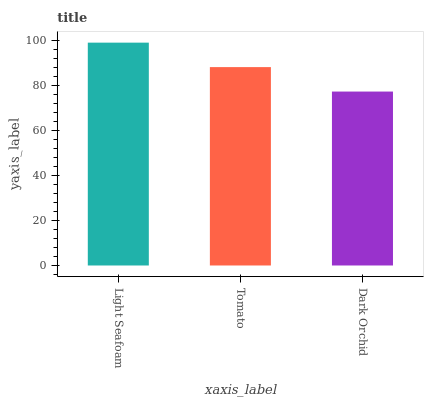Is Dark Orchid the minimum?
Answer yes or no. Yes. Is Light Seafoam the maximum?
Answer yes or no. Yes. Is Tomato the minimum?
Answer yes or no. No. Is Tomato the maximum?
Answer yes or no. No. Is Light Seafoam greater than Tomato?
Answer yes or no. Yes. Is Tomato less than Light Seafoam?
Answer yes or no. Yes. Is Tomato greater than Light Seafoam?
Answer yes or no. No. Is Light Seafoam less than Tomato?
Answer yes or no. No. Is Tomato the high median?
Answer yes or no. Yes. Is Tomato the low median?
Answer yes or no. Yes. Is Dark Orchid the high median?
Answer yes or no. No. Is Light Seafoam the low median?
Answer yes or no. No. 